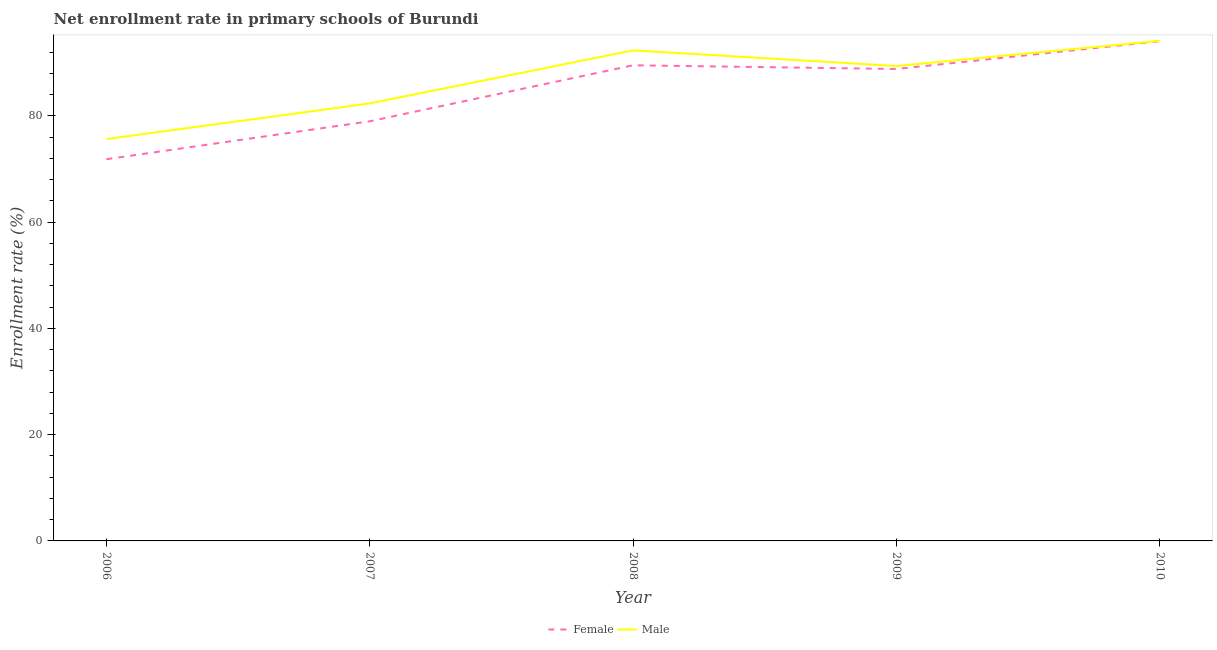How many different coloured lines are there?
Offer a very short reply. 2. What is the enrollment rate of male students in 2006?
Provide a succinct answer. 75.62. Across all years, what is the maximum enrollment rate of female students?
Offer a terse response. 94.03. Across all years, what is the minimum enrollment rate of male students?
Keep it short and to the point. 75.62. In which year was the enrollment rate of male students maximum?
Keep it short and to the point. 2010. In which year was the enrollment rate of male students minimum?
Your response must be concise. 2006. What is the total enrollment rate of male students in the graph?
Your answer should be compact. 433.73. What is the difference between the enrollment rate of male students in 2007 and that in 2008?
Keep it short and to the point. -9.98. What is the difference between the enrollment rate of female students in 2009 and the enrollment rate of male students in 2010?
Offer a terse response. -5.3. What is the average enrollment rate of female students per year?
Provide a succinct answer. 84.63. In the year 2009, what is the difference between the enrollment rate of female students and enrollment rate of male students?
Offer a very short reply. -0.56. What is the ratio of the enrollment rate of female students in 2007 to that in 2008?
Keep it short and to the point. 0.88. Is the enrollment rate of male students in 2006 less than that in 2010?
Your answer should be very brief. Yes. Is the difference between the enrollment rate of female students in 2006 and 2008 greater than the difference between the enrollment rate of male students in 2006 and 2008?
Your answer should be compact. No. What is the difference between the highest and the second highest enrollment rate of male students?
Your answer should be compact. 1.8. What is the difference between the highest and the lowest enrollment rate of female students?
Offer a very short reply. 22.21. In how many years, is the enrollment rate of male students greater than the average enrollment rate of male students taken over all years?
Your response must be concise. 3. Does the enrollment rate of female students monotonically increase over the years?
Your response must be concise. No. Where does the legend appear in the graph?
Offer a very short reply. Bottom center. How many legend labels are there?
Keep it short and to the point. 2. What is the title of the graph?
Offer a very short reply. Net enrollment rate in primary schools of Burundi. What is the label or title of the X-axis?
Provide a short and direct response. Year. What is the label or title of the Y-axis?
Offer a terse response. Enrollment rate (%). What is the Enrollment rate (%) in Female in 2006?
Offer a very short reply. 71.83. What is the Enrollment rate (%) of Male in 2006?
Give a very brief answer. 75.62. What is the Enrollment rate (%) in Female in 2007?
Your answer should be very brief. 78.96. What is the Enrollment rate (%) of Male in 2007?
Give a very brief answer. 82.33. What is the Enrollment rate (%) in Female in 2008?
Provide a succinct answer. 89.5. What is the Enrollment rate (%) in Male in 2008?
Provide a succinct answer. 92.31. What is the Enrollment rate (%) of Female in 2009?
Keep it short and to the point. 88.81. What is the Enrollment rate (%) of Male in 2009?
Offer a terse response. 89.37. What is the Enrollment rate (%) in Female in 2010?
Your response must be concise. 94.03. What is the Enrollment rate (%) of Male in 2010?
Provide a short and direct response. 94.11. Across all years, what is the maximum Enrollment rate (%) in Female?
Provide a succinct answer. 94.03. Across all years, what is the maximum Enrollment rate (%) in Male?
Give a very brief answer. 94.11. Across all years, what is the minimum Enrollment rate (%) of Female?
Your answer should be very brief. 71.83. Across all years, what is the minimum Enrollment rate (%) in Male?
Your response must be concise. 75.62. What is the total Enrollment rate (%) in Female in the graph?
Provide a short and direct response. 423.13. What is the total Enrollment rate (%) in Male in the graph?
Your response must be concise. 433.73. What is the difference between the Enrollment rate (%) in Female in 2006 and that in 2007?
Your answer should be compact. -7.13. What is the difference between the Enrollment rate (%) of Male in 2006 and that in 2007?
Give a very brief answer. -6.71. What is the difference between the Enrollment rate (%) of Female in 2006 and that in 2008?
Offer a terse response. -17.67. What is the difference between the Enrollment rate (%) in Male in 2006 and that in 2008?
Make the answer very short. -16.69. What is the difference between the Enrollment rate (%) of Female in 2006 and that in 2009?
Provide a short and direct response. -16.98. What is the difference between the Enrollment rate (%) of Male in 2006 and that in 2009?
Your answer should be compact. -13.75. What is the difference between the Enrollment rate (%) in Female in 2006 and that in 2010?
Your answer should be compact. -22.21. What is the difference between the Enrollment rate (%) in Male in 2006 and that in 2010?
Your answer should be very brief. -18.49. What is the difference between the Enrollment rate (%) in Female in 2007 and that in 2008?
Your answer should be compact. -10.54. What is the difference between the Enrollment rate (%) of Male in 2007 and that in 2008?
Your answer should be very brief. -9.98. What is the difference between the Enrollment rate (%) in Female in 2007 and that in 2009?
Offer a terse response. -9.84. What is the difference between the Enrollment rate (%) in Male in 2007 and that in 2009?
Give a very brief answer. -7.04. What is the difference between the Enrollment rate (%) in Female in 2007 and that in 2010?
Keep it short and to the point. -15.07. What is the difference between the Enrollment rate (%) in Male in 2007 and that in 2010?
Your answer should be compact. -11.78. What is the difference between the Enrollment rate (%) in Female in 2008 and that in 2009?
Provide a short and direct response. 0.7. What is the difference between the Enrollment rate (%) of Male in 2008 and that in 2009?
Your answer should be compact. 2.94. What is the difference between the Enrollment rate (%) of Female in 2008 and that in 2010?
Make the answer very short. -4.53. What is the difference between the Enrollment rate (%) in Male in 2008 and that in 2010?
Your answer should be compact. -1.8. What is the difference between the Enrollment rate (%) of Female in 2009 and that in 2010?
Make the answer very short. -5.23. What is the difference between the Enrollment rate (%) in Male in 2009 and that in 2010?
Make the answer very short. -4.74. What is the difference between the Enrollment rate (%) in Female in 2006 and the Enrollment rate (%) in Male in 2007?
Offer a very short reply. -10.5. What is the difference between the Enrollment rate (%) in Female in 2006 and the Enrollment rate (%) in Male in 2008?
Ensure brevity in your answer.  -20.48. What is the difference between the Enrollment rate (%) of Female in 2006 and the Enrollment rate (%) of Male in 2009?
Your answer should be very brief. -17.54. What is the difference between the Enrollment rate (%) of Female in 2006 and the Enrollment rate (%) of Male in 2010?
Provide a short and direct response. -22.28. What is the difference between the Enrollment rate (%) of Female in 2007 and the Enrollment rate (%) of Male in 2008?
Give a very brief answer. -13.35. What is the difference between the Enrollment rate (%) of Female in 2007 and the Enrollment rate (%) of Male in 2009?
Ensure brevity in your answer.  -10.4. What is the difference between the Enrollment rate (%) of Female in 2007 and the Enrollment rate (%) of Male in 2010?
Offer a terse response. -15.15. What is the difference between the Enrollment rate (%) of Female in 2008 and the Enrollment rate (%) of Male in 2009?
Provide a short and direct response. 0.14. What is the difference between the Enrollment rate (%) of Female in 2008 and the Enrollment rate (%) of Male in 2010?
Provide a succinct answer. -4.61. What is the difference between the Enrollment rate (%) in Female in 2009 and the Enrollment rate (%) in Male in 2010?
Give a very brief answer. -5.3. What is the average Enrollment rate (%) of Female per year?
Provide a short and direct response. 84.63. What is the average Enrollment rate (%) of Male per year?
Make the answer very short. 86.75. In the year 2006, what is the difference between the Enrollment rate (%) in Female and Enrollment rate (%) in Male?
Give a very brief answer. -3.79. In the year 2007, what is the difference between the Enrollment rate (%) in Female and Enrollment rate (%) in Male?
Your answer should be compact. -3.37. In the year 2008, what is the difference between the Enrollment rate (%) of Female and Enrollment rate (%) of Male?
Offer a very short reply. -2.81. In the year 2009, what is the difference between the Enrollment rate (%) in Female and Enrollment rate (%) in Male?
Offer a very short reply. -0.56. In the year 2010, what is the difference between the Enrollment rate (%) in Female and Enrollment rate (%) in Male?
Your answer should be very brief. -0.08. What is the ratio of the Enrollment rate (%) of Female in 2006 to that in 2007?
Your answer should be very brief. 0.91. What is the ratio of the Enrollment rate (%) of Male in 2006 to that in 2007?
Keep it short and to the point. 0.92. What is the ratio of the Enrollment rate (%) of Female in 2006 to that in 2008?
Give a very brief answer. 0.8. What is the ratio of the Enrollment rate (%) of Male in 2006 to that in 2008?
Keep it short and to the point. 0.82. What is the ratio of the Enrollment rate (%) in Female in 2006 to that in 2009?
Keep it short and to the point. 0.81. What is the ratio of the Enrollment rate (%) of Male in 2006 to that in 2009?
Provide a short and direct response. 0.85. What is the ratio of the Enrollment rate (%) in Female in 2006 to that in 2010?
Make the answer very short. 0.76. What is the ratio of the Enrollment rate (%) in Male in 2006 to that in 2010?
Offer a very short reply. 0.8. What is the ratio of the Enrollment rate (%) in Female in 2007 to that in 2008?
Your answer should be very brief. 0.88. What is the ratio of the Enrollment rate (%) of Male in 2007 to that in 2008?
Offer a terse response. 0.89. What is the ratio of the Enrollment rate (%) in Female in 2007 to that in 2009?
Offer a very short reply. 0.89. What is the ratio of the Enrollment rate (%) in Male in 2007 to that in 2009?
Make the answer very short. 0.92. What is the ratio of the Enrollment rate (%) in Female in 2007 to that in 2010?
Keep it short and to the point. 0.84. What is the ratio of the Enrollment rate (%) of Male in 2007 to that in 2010?
Offer a very short reply. 0.87. What is the ratio of the Enrollment rate (%) of Male in 2008 to that in 2009?
Offer a terse response. 1.03. What is the ratio of the Enrollment rate (%) in Female in 2008 to that in 2010?
Give a very brief answer. 0.95. What is the ratio of the Enrollment rate (%) of Male in 2008 to that in 2010?
Make the answer very short. 0.98. What is the ratio of the Enrollment rate (%) of Female in 2009 to that in 2010?
Give a very brief answer. 0.94. What is the ratio of the Enrollment rate (%) of Male in 2009 to that in 2010?
Your answer should be very brief. 0.95. What is the difference between the highest and the second highest Enrollment rate (%) of Female?
Offer a terse response. 4.53. What is the difference between the highest and the second highest Enrollment rate (%) in Male?
Provide a short and direct response. 1.8. What is the difference between the highest and the lowest Enrollment rate (%) in Female?
Keep it short and to the point. 22.21. What is the difference between the highest and the lowest Enrollment rate (%) of Male?
Provide a succinct answer. 18.49. 